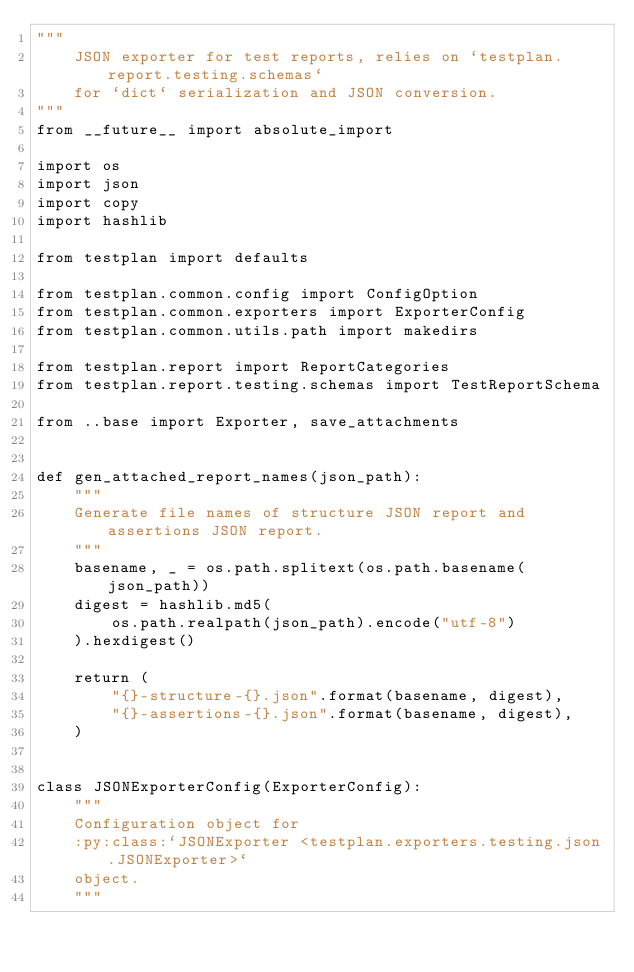Convert code to text. <code><loc_0><loc_0><loc_500><loc_500><_Python_>"""
    JSON exporter for test reports, relies on `testplan.report.testing.schemas`
    for `dict` serialization and JSON conversion.
"""
from __future__ import absolute_import

import os
import json
import copy
import hashlib

from testplan import defaults

from testplan.common.config import ConfigOption
from testplan.common.exporters import ExporterConfig
from testplan.common.utils.path import makedirs

from testplan.report import ReportCategories
from testplan.report.testing.schemas import TestReportSchema

from ..base import Exporter, save_attachments


def gen_attached_report_names(json_path):
    """
    Generate file names of structure JSON report and assertions JSON report.
    """
    basename, _ = os.path.splitext(os.path.basename(json_path))
    digest = hashlib.md5(
        os.path.realpath(json_path).encode("utf-8")
    ).hexdigest()

    return (
        "{}-structure-{}.json".format(basename, digest),
        "{}-assertions-{}.json".format(basename, digest),
    )


class JSONExporterConfig(ExporterConfig):
    """
    Configuration object for
    :py:class:`JSONExporter <testplan.exporters.testing.json.JSONExporter>`
    object.
    """
</code> 